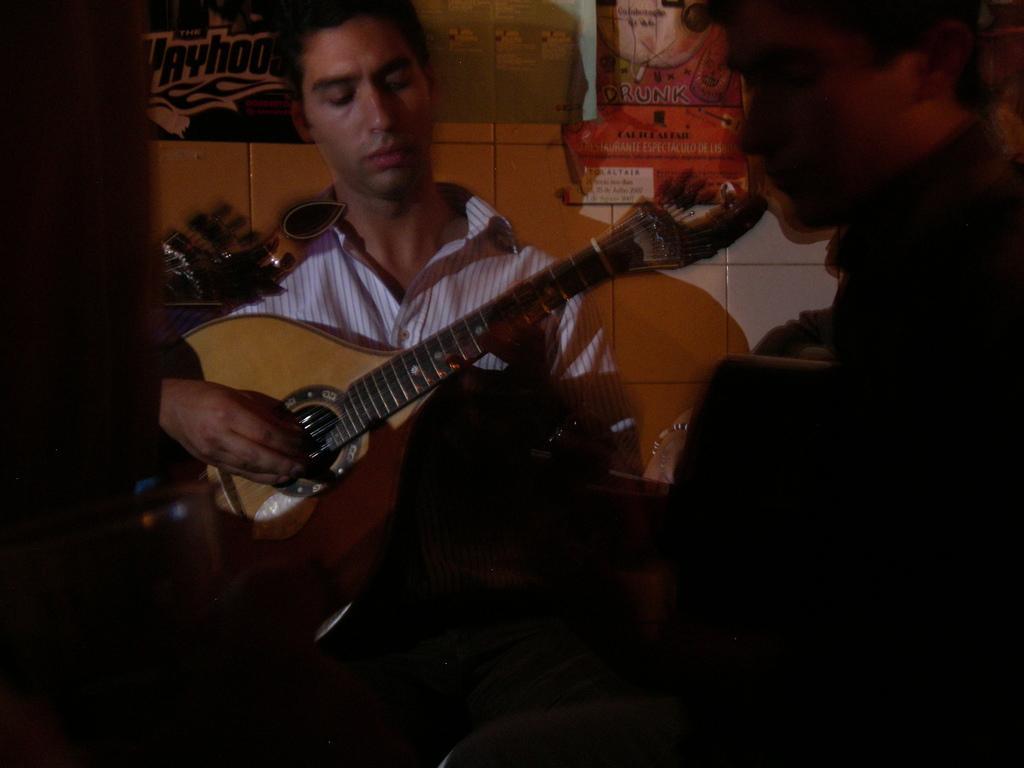Can you describe this image briefly? In the image we can see two persons were sitting and holding guitar,In there background there is a wall. 